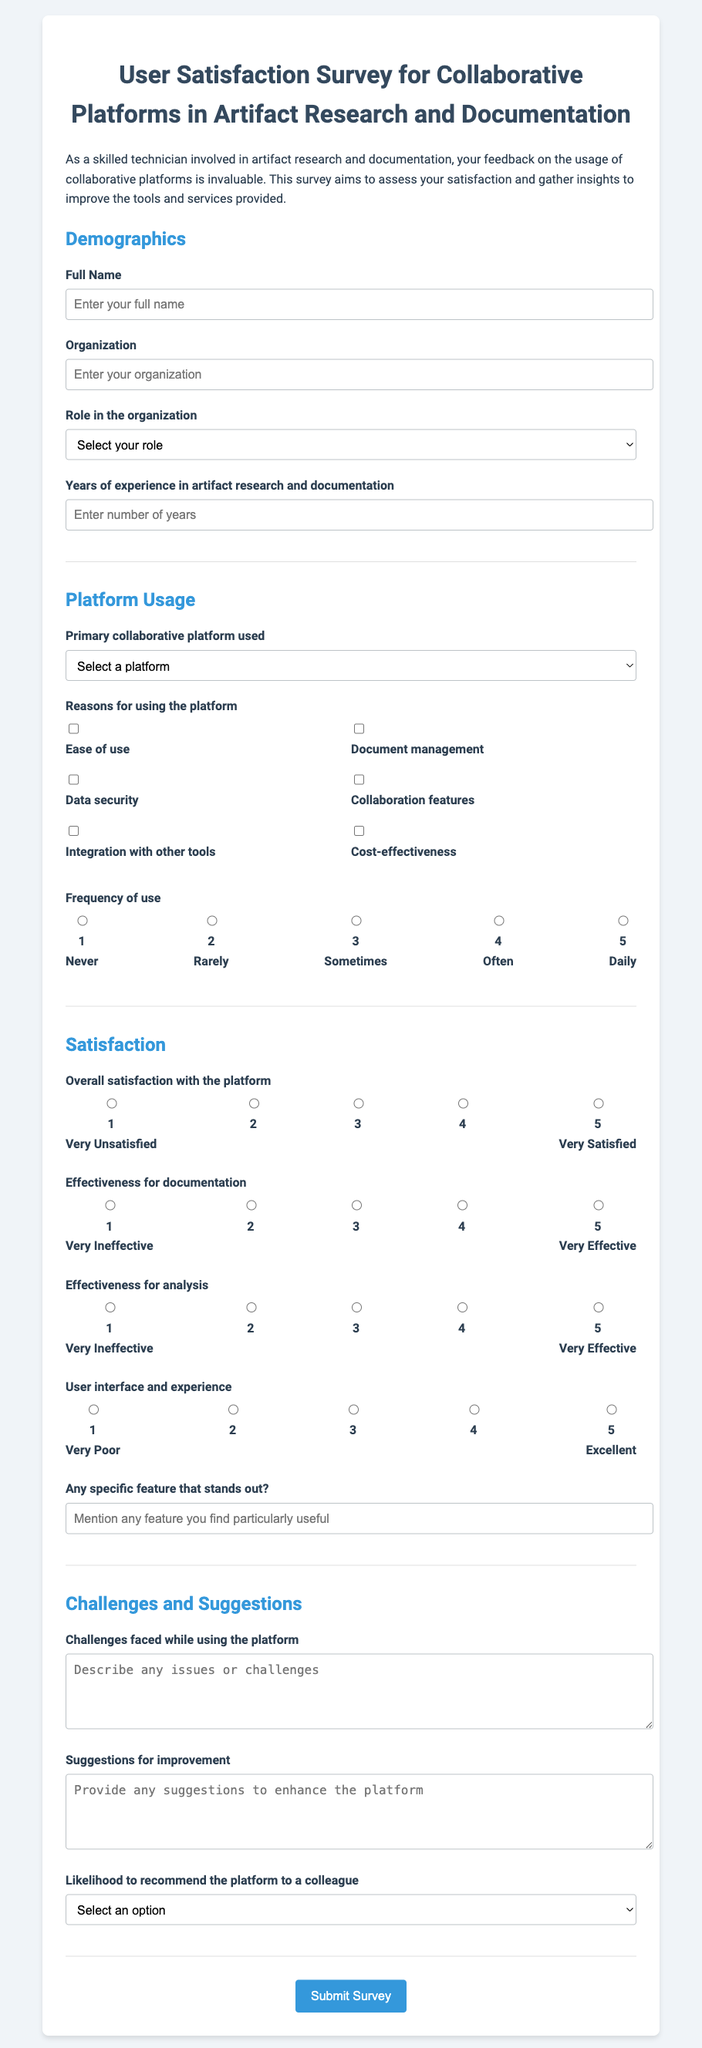What is the title of the survey? The title of the survey can be found at the top of the document.
Answer: User Satisfaction Survey for Collaborative Platforms in Artifact Research and Documentation How many years of experience are asked about in the survey? The section on demographics includes a question regarding years of experience.
Answer: Years of experience in artifact research and documentation What is the first question in the Platform Usage section? The first question under the Platform Usage section addresses the primary collaborative platform used.
Answer: Primary collaborative platform used Which platform is mentioned as an option for usage? The platforms listed in the survey are detailed in the Platform Usage section.
Answer: Google Drive What score represents 'Very Satisfied' in the satisfaction rating? The satisfaction ratings include options, and 'Very Satisfied' corresponds to a specific numeric rating.
Answer: 5 What kind of response is requested for challenges faced? The survey prompts respondents to describe their challenges in a specific format.
Answer: Text area What is the fifth reason listed for using the platform? The reasons for using the platform are found in checkboxes within the Platform Usage section.
Answer: Cost-effectiveness What feature can users specify as particularly useful? There’s a question that asks for a specific feature that stands out in usage.
Answer: Mention any feature you find particularly useful 